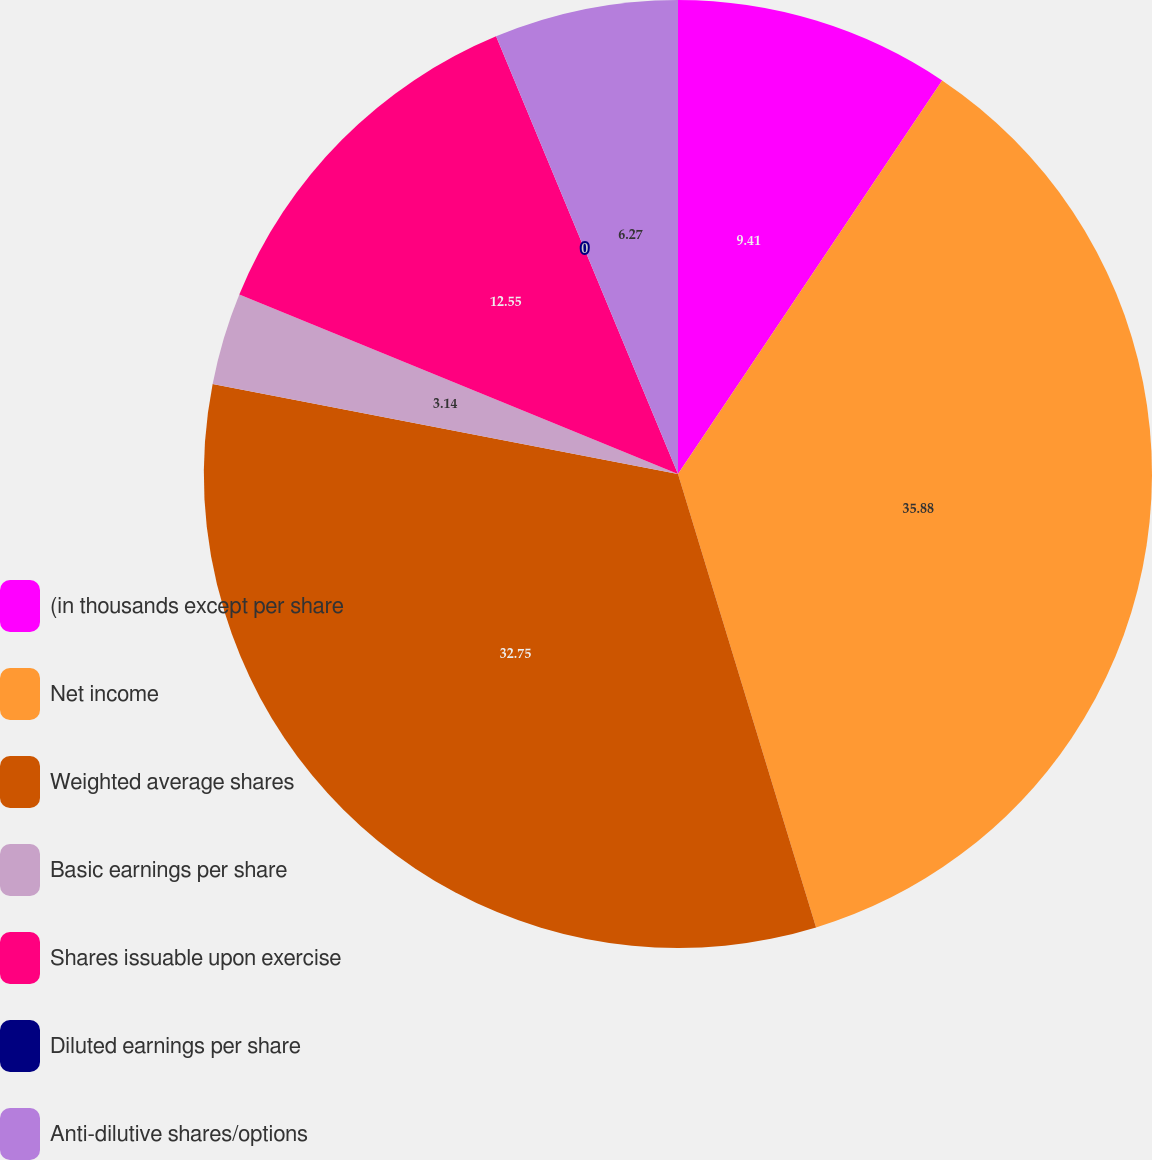Convert chart to OTSL. <chart><loc_0><loc_0><loc_500><loc_500><pie_chart><fcel>(in thousands except per share<fcel>Net income<fcel>Weighted average shares<fcel>Basic earnings per share<fcel>Shares issuable upon exercise<fcel>Diluted earnings per share<fcel>Anti-dilutive shares/options<nl><fcel>9.41%<fcel>35.89%<fcel>32.75%<fcel>3.14%<fcel>12.55%<fcel>0.0%<fcel>6.27%<nl></chart> 